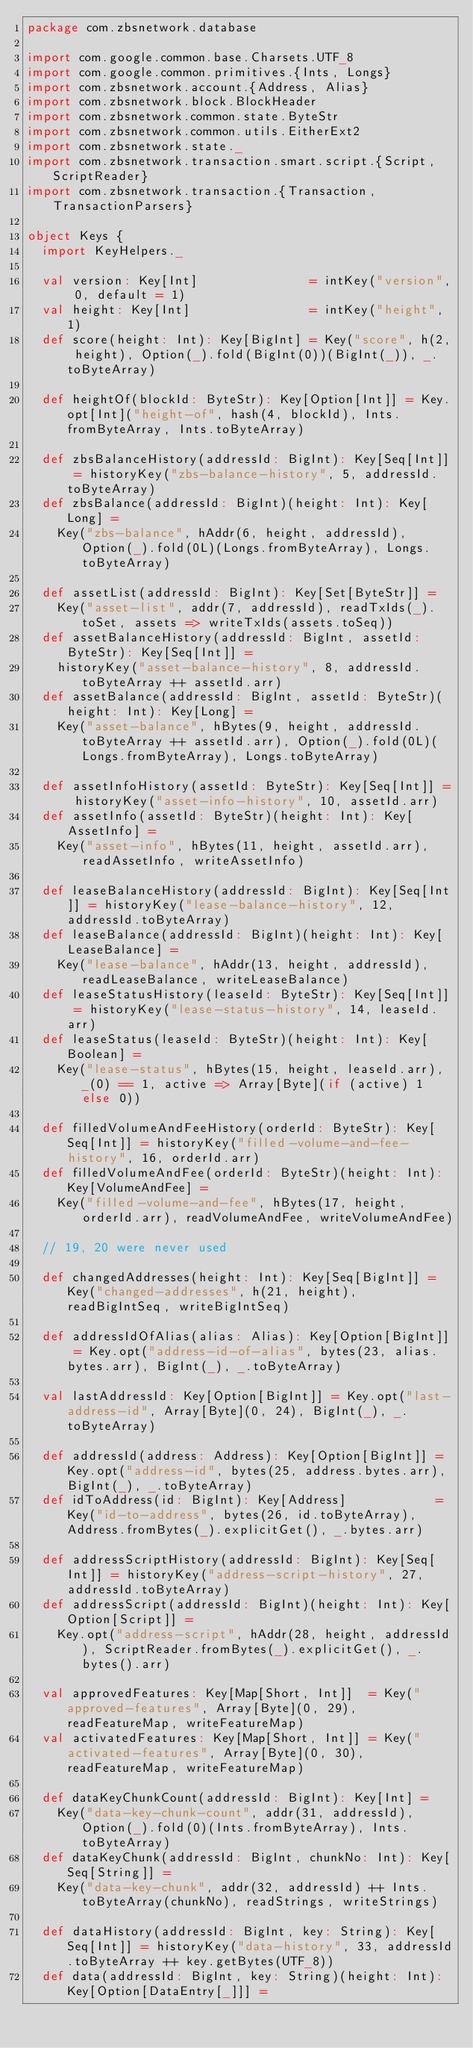Convert code to text. <code><loc_0><loc_0><loc_500><loc_500><_Scala_>package com.zbsnetwork.database

import com.google.common.base.Charsets.UTF_8
import com.google.common.primitives.{Ints, Longs}
import com.zbsnetwork.account.{Address, Alias}
import com.zbsnetwork.block.BlockHeader
import com.zbsnetwork.common.state.ByteStr
import com.zbsnetwork.common.utils.EitherExt2
import com.zbsnetwork.state._
import com.zbsnetwork.transaction.smart.script.{Script, ScriptReader}
import com.zbsnetwork.transaction.{Transaction, TransactionParsers}

object Keys {
  import KeyHelpers._

  val version: Key[Int]               = intKey("version", 0, default = 1)
  val height: Key[Int]                = intKey("height", 1)
  def score(height: Int): Key[BigInt] = Key("score", h(2, height), Option(_).fold(BigInt(0))(BigInt(_)), _.toByteArray)

  def heightOf(blockId: ByteStr): Key[Option[Int]] = Key.opt[Int]("height-of", hash(4, blockId), Ints.fromByteArray, Ints.toByteArray)

  def zbsBalanceHistory(addressId: BigInt): Key[Seq[Int]] = historyKey("zbs-balance-history", 5, addressId.toByteArray)
  def zbsBalance(addressId: BigInt)(height: Int): Key[Long] =
    Key("zbs-balance", hAddr(6, height, addressId), Option(_).fold(0L)(Longs.fromByteArray), Longs.toByteArray)

  def assetList(addressId: BigInt): Key[Set[ByteStr]] =
    Key("asset-list", addr(7, addressId), readTxIds(_).toSet, assets => writeTxIds(assets.toSeq))
  def assetBalanceHistory(addressId: BigInt, assetId: ByteStr): Key[Seq[Int]] =
    historyKey("asset-balance-history", 8, addressId.toByteArray ++ assetId.arr)
  def assetBalance(addressId: BigInt, assetId: ByteStr)(height: Int): Key[Long] =
    Key("asset-balance", hBytes(9, height, addressId.toByteArray ++ assetId.arr), Option(_).fold(0L)(Longs.fromByteArray), Longs.toByteArray)

  def assetInfoHistory(assetId: ByteStr): Key[Seq[Int]] = historyKey("asset-info-history", 10, assetId.arr)
  def assetInfo(assetId: ByteStr)(height: Int): Key[AssetInfo] =
    Key("asset-info", hBytes(11, height, assetId.arr), readAssetInfo, writeAssetInfo)

  def leaseBalanceHistory(addressId: BigInt): Key[Seq[Int]] = historyKey("lease-balance-history", 12, addressId.toByteArray)
  def leaseBalance(addressId: BigInt)(height: Int): Key[LeaseBalance] =
    Key("lease-balance", hAddr(13, height, addressId), readLeaseBalance, writeLeaseBalance)
  def leaseStatusHistory(leaseId: ByteStr): Key[Seq[Int]] = historyKey("lease-status-history", 14, leaseId.arr)
  def leaseStatus(leaseId: ByteStr)(height: Int): Key[Boolean] =
    Key("lease-status", hBytes(15, height, leaseId.arr), _(0) == 1, active => Array[Byte](if (active) 1 else 0))

  def filledVolumeAndFeeHistory(orderId: ByteStr): Key[Seq[Int]] = historyKey("filled-volume-and-fee-history", 16, orderId.arr)
  def filledVolumeAndFee(orderId: ByteStr)(height: Int): Key[VolumeAndFee] =
    Key("filled-volume-and-fee", hBytes(17, height, orderId.arr), readVolumeAndFee, writeVolumeAndFee)

  // 19, 20 were never used

  def changedAddresses(height: Int): Key[Seq[BigInt]] = Key("changed-addresses", h(21, height), readBigIntSeq, writeBigIntSeq)

  def addressIdOfAlias(alias: Alias): Key[Option[BigInt]] = Key.opt("address-id-of-alias", bytes(23, alias.bytes.arr), BigInt(_), _.toByteArray)

  val lastAddressId: Key[Option[BigInt]] = Key.opt("last-address-id", Array[Byte](0, 24), BigInt(_), _.toByteArray)

  def addressId(address: Address): Key[Option[BigInt]] = Key.opt("address-id", bytes(25, address.bytes.arr), BigInt(_), _.toByteArray)
  def idToAddress(id: BigInt): Key[Address]            = Key("id-to-address", bytes(26, id.toByteArray), Address.fromBytes(_).explicitGet(), _.bytes.arr)

  def addressScriptHistory(addressId: BigInt): Key[Seq[Int]] = historyKey("address-script-history", 27, addressId.toByteArray)
  def addressScript(addressId: BigInt)(height: Int): Key[Option[Script]] =
    Key.opt("address-script", hAddr(28, height, addressId), ScriptReader.fromBytes(_).explicitGet(), _.bytes().arr)

  val approvedFeatures: Key[Map[Short, Int]]  = Key("approved-features", Array[Byte](0, 29), readFeatureMap, writeFeatureMap)
  val activatedFeatures: Key[Map[Short, Int]] = Key("activated-features", Array[Byte](0, 30), readFeatureMap, writeFeatureMap)

  def dataKeyChunkCount(addressId: BigInt): Key[Int] =
    Key("data-key-chunk-count", addr(31, addressId), Option(_).fold(0)(Ints.fromByteArray), Ints.toByteArray)
  def dataKeyChunk(addressId: BigInt, chunkNo: Int): Key[Seq[String]] =
    Key("data-key-chunk", addr(32, addressId) ++ Ints.toByteArray(chunkNo), readStrings, writeStrings)

  def dataHistory(addressId: BigInt, key: String): Key[Seq[Int]] = historyKey("data-history", 33, addressId.toByteArray ++ key.getBytes(UTF_8))
  def data(addressId: BigInt, key: String)(height: Int): Key[Option[DataEntry[_]]] =</code> 